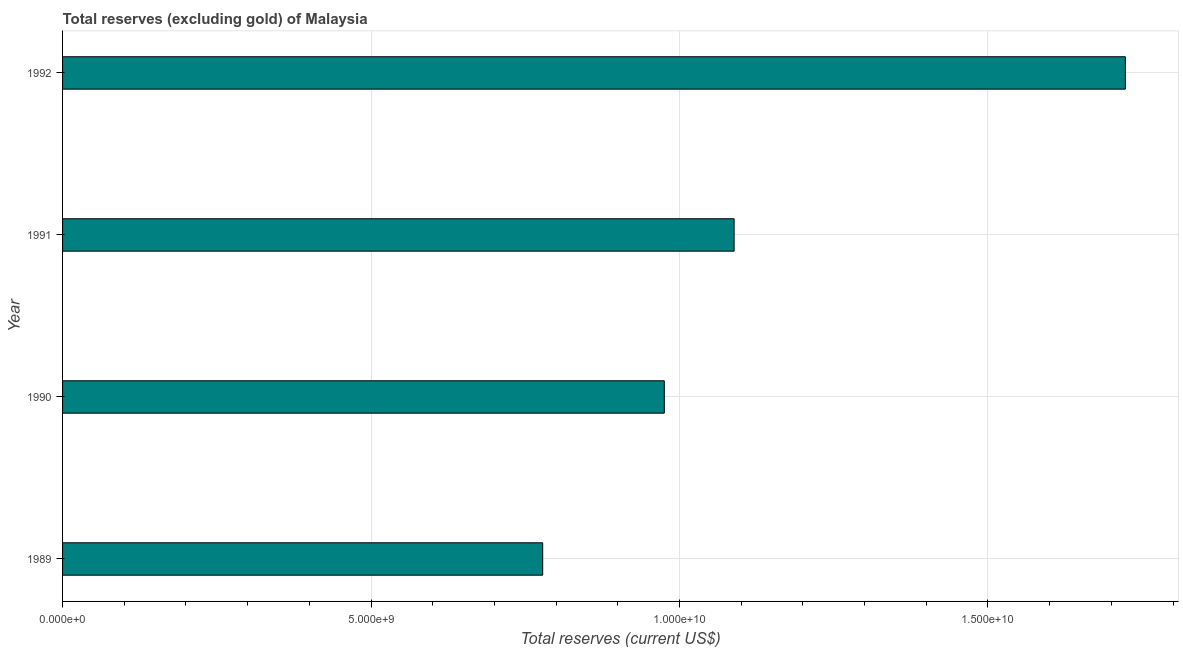Does the graph contain grids?
Your answer should be compact. Yes. What is the title of the graph?
Give a very brief answer. Total reserves (excluding gold) of Malaysia. What is the label or title of the X-axis?
Provide a succinct answer. Total reserves (current US$). What is the label or title of the Y-axis?
Your answer should be very brief. Year. What is the total reserves (excluding gold) in 1989?
Make the answer very short. 7.78e+09. Across all years, what is the maximum total reserves (excluding gold)?
Make the answer very short. 1.72e+1. Across all years, what is the minimum total reserves (excluding gold)?
Provide a short and direct response. 7.78e+09. In which year was the total reserves (excluding gold) maximum?
Offer a very short reply. 1992. In which year was the total reserves (excluding gold) minimum?
Ensure brevity in your answer.  1989. What is the sum of the total reserves (excluding gold)?
Your answer should be compact. 4.57e+1. What is the difference between the total reserves (excluding gold) in 1990 and 1992?
Your answer should be compact. -7.47e+09. What is the average total reserves (excluding gold) per year?
Offer a terse response. 1.14e+1. What is the median total reserves (excluding gold)?
Give a very brief answer. 1.03e+1. In how many years, is the total reserves (excluding gold) greater than 2000000000 US$?
Your answer should be compact. 4. What is the ratio of the total reserves (excluding gold) in 1990 to that in 1991?
Ensure brevity in your answer.  0.9. Is the total reserves (excluding gold) in 1991 less than that in 1992?
Your response must be concise. Yes. What is the difference between the highest and the second highest total reserves (excluding gold)?
Offer a very short reply. 6.34e+09. Is the sum of the total reserves (excluding gold) in 1990 and 1992 greater than the maximum total reserves (excluding gold) across all years?
Provide a succinct answer. Yes. What is the difference between the highest and the lowest total reserves (excluding gold)?
Your answer should be very brief. 9.44e+09. In how many years, is the total reserves (excluding gold) greater than the average total reserves (excluding gold) taken over all years?
Make the answer very short. 1. How many years are there in the graph?
Your response must be concise. 4. What is the difference between two consecutive major ticks on the X-axis?
Make the answer very short. 5.00e+09. What is the Total reserves (current US$) in 1989?
Provide a short and direct response. 7.78e+09. What is the Total reserves (current US$) of 1990?
Give a very brief answer. 9.75e+09. What is the Total reserves (current US$) in 1991?
Offer a terse response. 1.09e+1. What is the Total reserves (current US$) in 1992?
Offer a very short reply. 1.72e+1. What is the difference between the Total reserves (current US$) in 1989 and 1990?
Offer a very short reply. -1.97e+09. What is the difference between the Total reserves (current US$) in 1989 and 1991?
Offer a terse response. -3.10e+09. What is the difference between the Total reserves (current US$) in 1989 and 1992?
Provide a succinct answer. -9.44e+09. What is the difference between the Total reserves (current US$) in 1990 and 1991?
Give a very brief answer. -1.13e+09. What is the difference between the Total reserves (current US$) in 1990 and 1992?
Your answer should be very brief. -7.47e+09. What is the difference between the Total reserves (current US$) in 1991 and 1992?
Provide a succinct answer. -6.34e+09. What is the ratio of the Total reserves (current US$) in 1989 to that in 1990?
Keep it short and to the point. 0.8. What is the ratio of the Total reserves (current US$) in 1989 to that in 1991?
Your answer should be compact. 0.71. What is the ratio of the Total reserves (current US$) in 1989 to that in 1992?
Offer a terse response. 0.45. What is the ratio of the Total reserves (current US$) in 1990 to that in 1991?
Your response must be concise. 0.9. What is the ratio of the Total reserves (current US$) in 1990 to that in 1992?
Keep it short and to the point. 0.57. What is the ratio of the Total reserves (current US$) in 1991 to that in 1992?
Offer a very short reply. 0.63. 